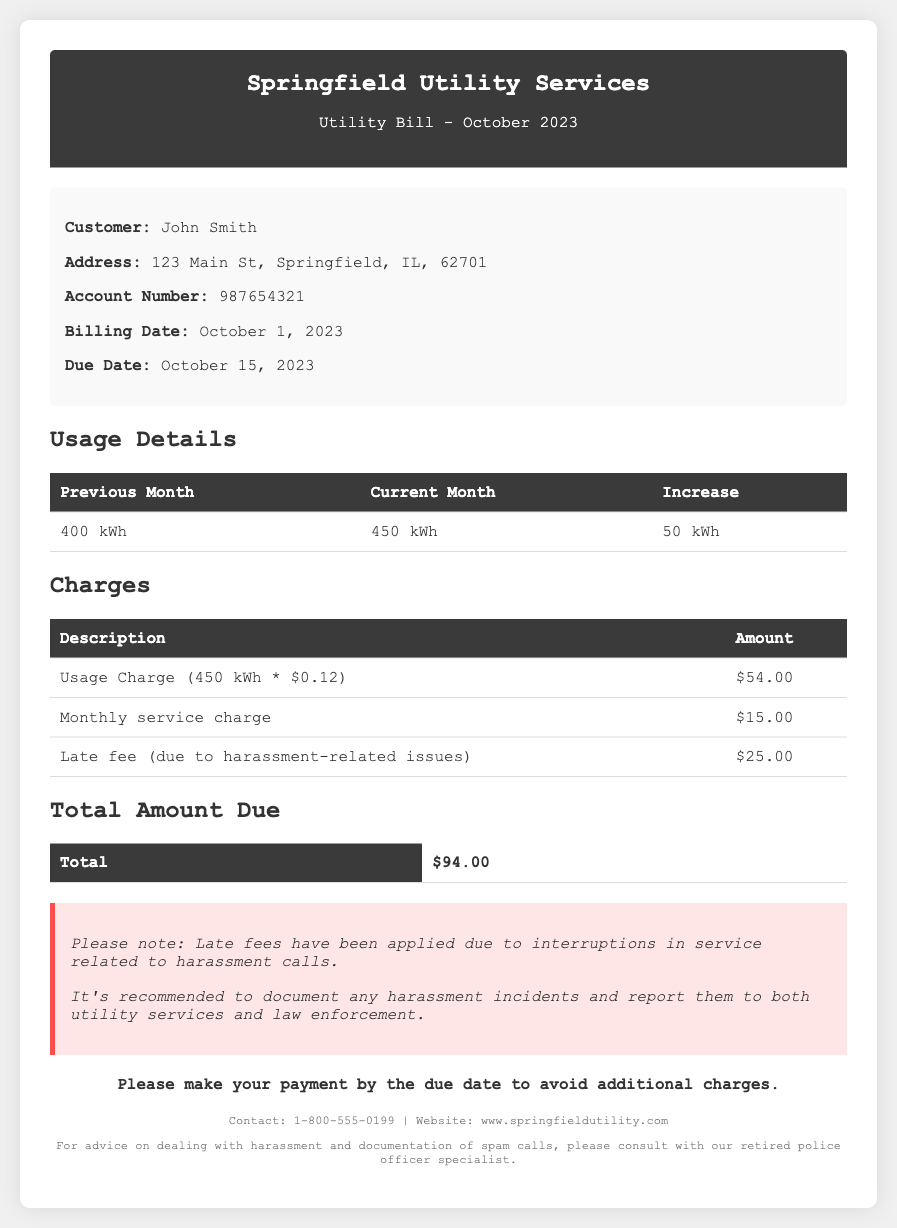What is the billing date? The billing date is specified in the document as October 1, 2023.
Answer: October 1, 2023 What is the total amount due? The total amount due is calculated as the sum of all charges listed, which is $94.00.
Answer: $94.00 Who is the customer? The customer’s name is listed in the customer information section as John Smith.
Answer: John Smith What is the due date? The due date for the bill is provided in the document as October 15, 2023.
Answer: October 15, 2023 What is the usage charge amount? The usage charge for 450 kWh is detailed in the charges section as $54.00.
Answer: $54.00 What increased the charge compared to the previous month? The document states that the increase in usage from the previous month to the current month is due to an increase of 50 kWh.
Answer: 50 kWh What is the late fee related to? The late fee is specifically noted as being due to harassment-related issues.
Answer: harassment-related issues What should you do regarding harassment incidents? The document recommends documenting any harassment incidents and reporting them to relevant authorities.
Answer: document and report What is included in the charges section? The charges section includes a usage charge, monthly service charge, and late fee.
Answer: usage charge, monthly service charge, late fee 